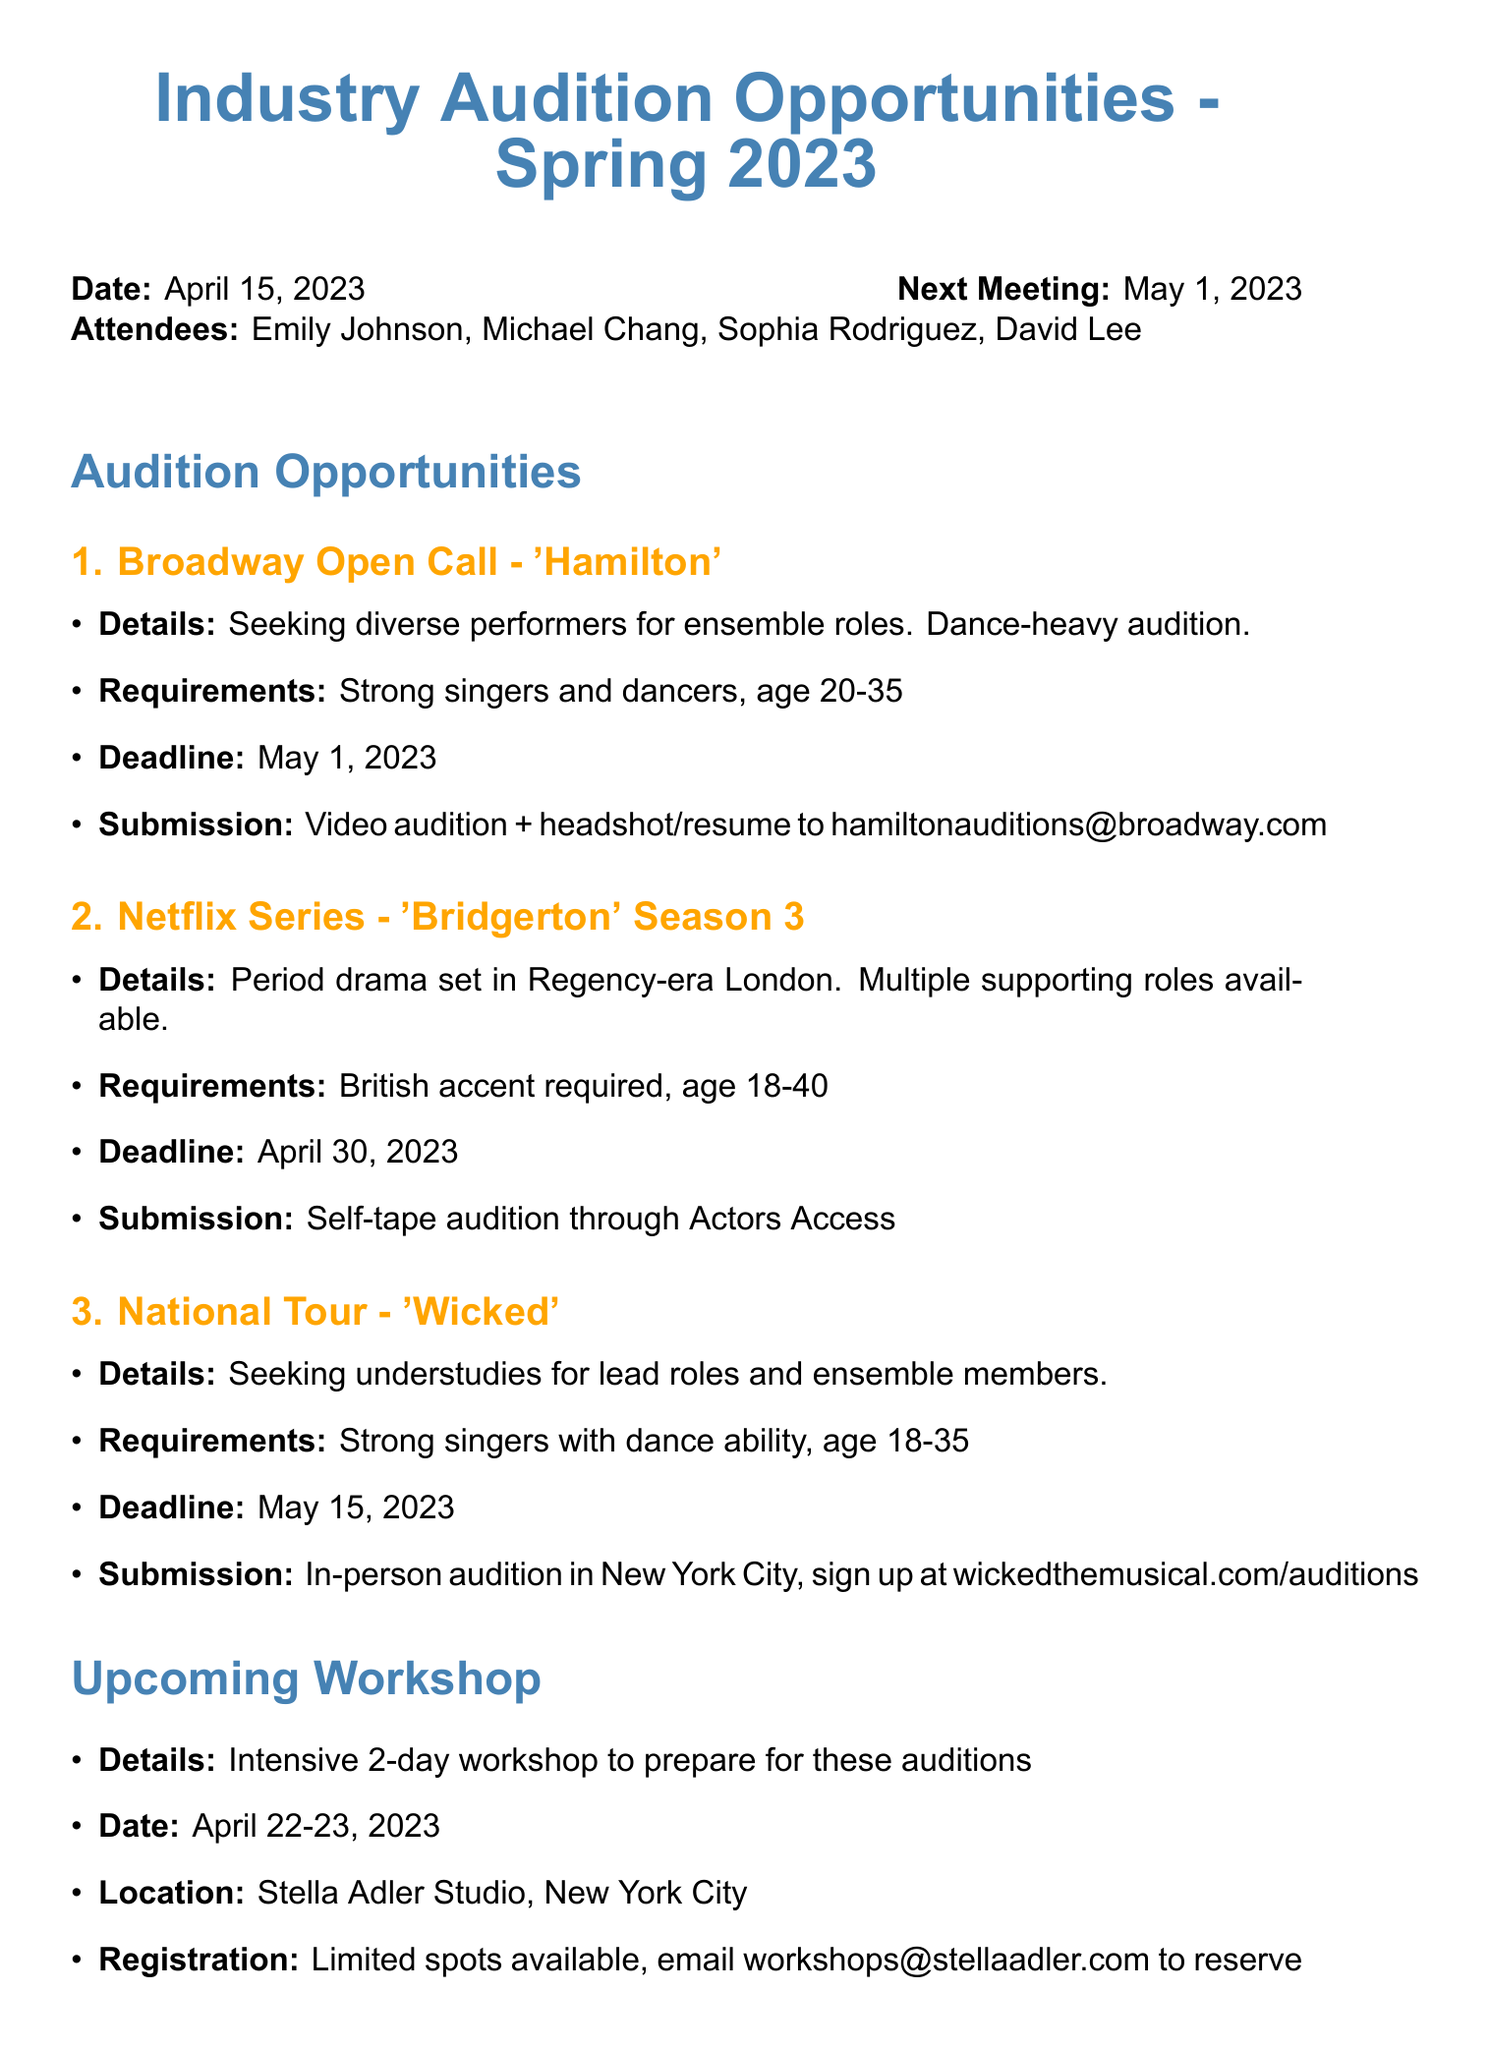What is the date of the next meeting? The next meeting is scheduled for May 1, 2023, as mentioned in the document.
Answer: May 1, 2023 Who is the primary contact for the 'Hamilton' audition submissions? The contact email for the 'Hamilton' audition is provided in the submission details.
Answer: hamiltonauditions@broadway.com What is the age requirement for the 'Bridgerton' auditions? The 'Bridgerton' audition specifies that participants should be aged between 18 and 40.
Answer: 18-40 When is the audition workshop taking place? The document provides the specific dates for the upcoming audition workshop.
Answer: April 22-23, 2023 What is the submission method for the 'Wicked' auditions? The submission method for 'Wicked' auditions is described in the relevant section of the document.
Answer: In-person audition What are the action items related to the 'Hamilton' audition? Action items specific to 'Hamilton' are mentioned, indicating what preparations are required.
Answer: Prepare 16-bar musical theater and pop/rock selections What kind of roles are available for the 'Wicked' auditions? The document states the types of roles that are being sought for the 'Wicked' auditions.
Answer: Understudies for lead roles and ensemble members What is the location of the audition workshop? The document specifies where the audition workshop will be held.
Answer: Stella Adler Studio, New York City 